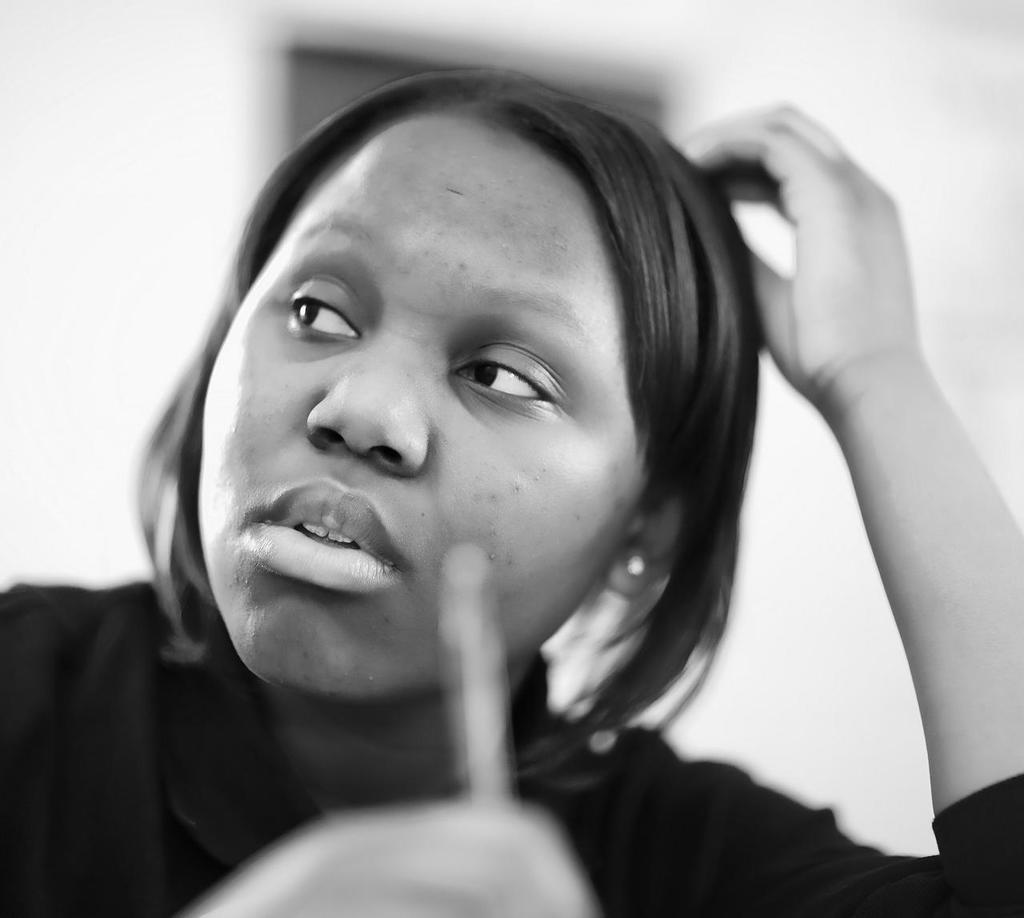What is the color scheme of the image? The image is black and white. What can be seen in the image? There is a person sitting in the image. What is the person holding? The person is holding a pen. Can you tell me how many zebras are smiling in the image? There are no zebras present in the image, and therefore no such activity can be observed. 